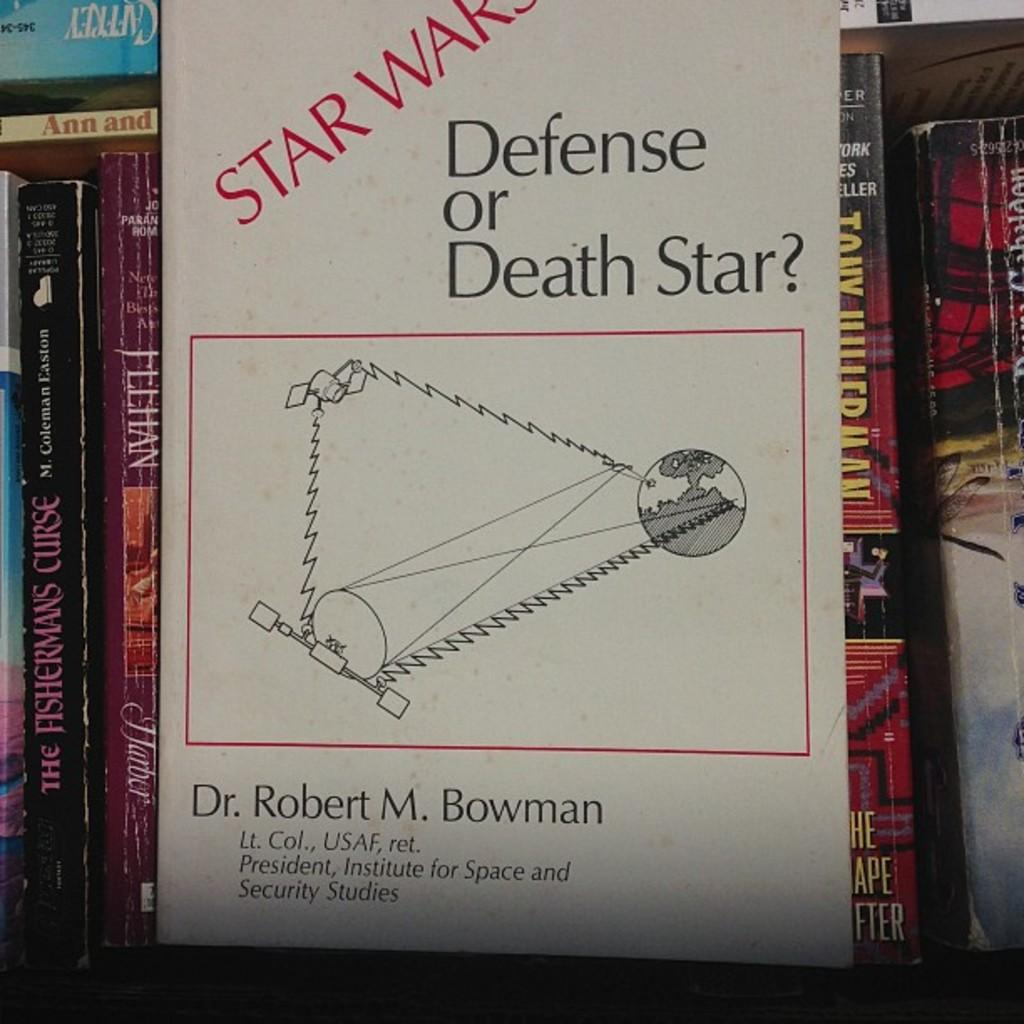<image>
Offer a succinct explanation of the picture presented. A book called Star Wars Defense or Death Star? by Dr. Robert M. Bowman. 